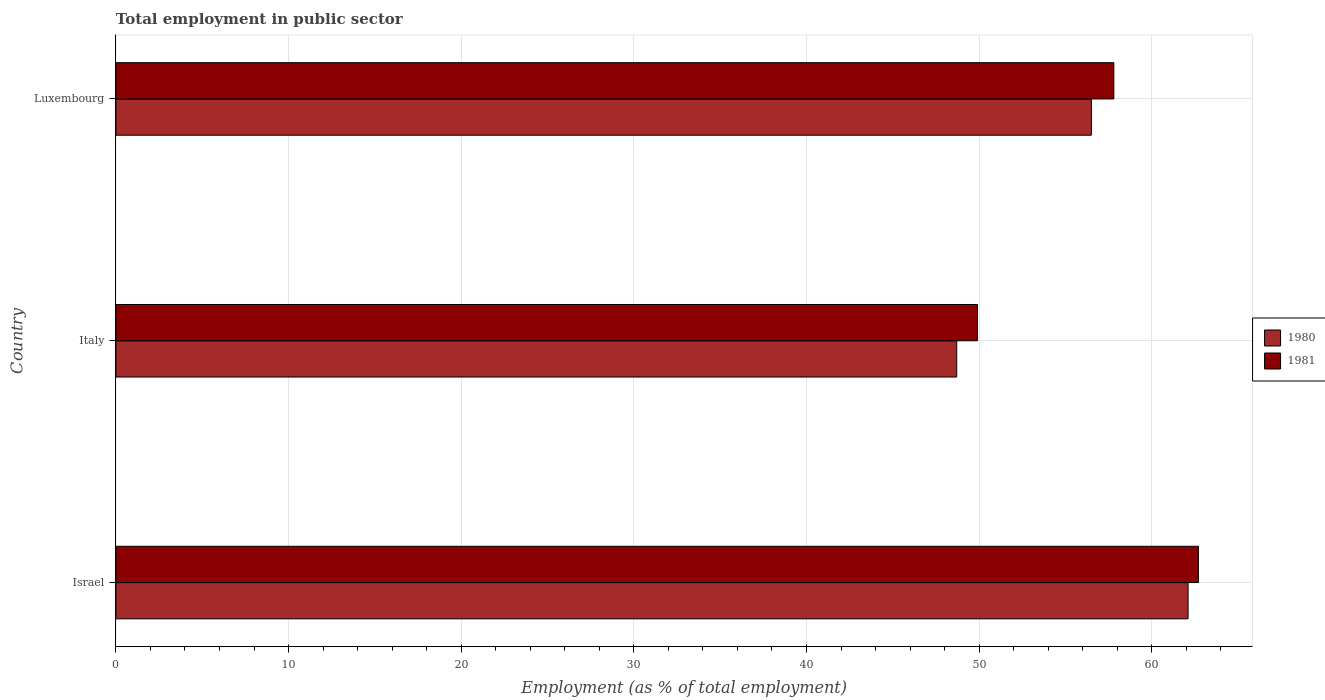How many groups of bars are there?
Your answer should be very brief. 3. In how many cases, is the number of bars for a given country not equal to the number of legend labels?
Offer a very short reply. 0. What is the employment in public sector in 1980 in Israel?
Your response must be concise. 62.1. Across all countries, what is the maximum employment in public sector in 1980?
Offer a very short reply. 62.1. Across all countries, what is the minimum employment in public sector in 1980?
Offer a terse response. 48.7. In which country was the employment in public sector in 1981 maximum?
Give a very brief answer. Israel. In which country was the employment in public sector in 1980 minimum?
Ensure brevity in your answer.  Italy. What is the total employment in public sector in 1980 in the graph?
Keep it short and to the point. 167.3. What is the difference between the employment in public sector in 1980 in Italy and that in Luxembourg?
Your answer should be very brief. -7.8. What is the difference between the employment in public sector in 1980 in Luxembourg and the employment in public sector in 1981 in Israel?
Offer a terse response. -6.2. What is the average employment in public sector in 1981 per country?
Give a very brief answer. 56.8. What is the difference between the employment in public sector in 1980 and employment in public sector in 1981 in Israel?
Your response must be concise. -0.6. What is the ratio of the employment in public sector in 1980 in Israel to that in Italy?
Provide a succinct answer. 1.28. What is the difference between the highest and the second highest employment in public sector in 1980?
Provide a succinct answer. 5.6. What is the difference between the highest and the lowest employment in public sector in 1980?
Provide a succinct answer. 13.4. Is the sum of the employment in public sector in 1980 in Israel and Italy greater than the maximum employment in public sector in 1981 across all countries?
Your answer should be compact. Yes. How many bars are there?
Ensure brevity in your answer.  6. Are all the bars in the graph horizontal?
Your response must be concise. Yes. What is the difference between two consecutive major ticks on the X-axis?
Provide a succinct answer. 10. Are the values on the major ticks of X-axis written in scientific E-notation?
Your answer should be compact. No. Does the graph contain grids?
Keep it short and to the point. Yes. Where does the legend appear in the graph?
Provide a short and direct response. Center right. What is the title of the graph?
Provide a succinct answer. Total employment in public sector. What is the label or title of the X-axis?
Your answer should be compact. Employment (as % of total employment). What is the label or title of the Y-axis?
Ensure brevity in your answer.  Country. What is the Employment (as % of total employment) of 1980 in Israel?
Provide a succinct answer. 62.1. What is the Employment (as % of total employment) of 1981 in Israel?
Make the answer very short. 62.7. What is the Employment (as % of total employment) in 1980 in Italy?
Provide a short and direct response. 48.7. What is the Employment (as % of total employment) in 1981 in Italy?
Keep it short and to the point. 49.9. What is the Employment (as % of total employment) in 1980 in Luxembourg?
Provide a short and direct response. 56.5. What is the Employment (as % of total employment) in 1981 in Luxembourg?
Give a very brief answer. 57.8. Across all countries, what is the maximum Employment (as % of total employment) of 1980?
Provide a short and direct response. 62.1. Across all countries, what is the maximum Employment (as % of total employment) in 1981?
Give a very brief answer. 62.7. Across all countries, what is the minimum Employment (as % of total employment) of 1980?
Make the answer very short. 48.7. Across all countries, what is the minimum Employment (as % of total employment) in 1981?
Provide a succinct answer. 49.9. What is the total Employment (as % of total employment) in 1980 in the graph?
Provide a short and direct response. 167.3. What is the total Employment (as % of total employment) in 1981 in the graph?
Your response must be concise. 170.4. What is the difference between the Employment (as % of total employment) in 1981 in Israel and that in Luxembourg?
Provide a short and direct response. 4.9. What is the difference between the Employment (as % of total employment) of 1980 in Israel and the Employment (as % of total employment) of 1981 in Italy?
Your answer should be compact. 12.2. What is the average Employment (as % of total employment) of 1980 per country?
Keep it short and to the point. 55.77. What is the average Employment (as % of total employment) of 1981 per country?
Provide a short and direct response. 56.8. What is the difference between the Employment (as % of total employment) in 1980 and Employment (as % of total employment) in 1981 in Luxembourg?
Keep it short and to the point. -1.3. What is the ratio of the Employment (as % of total employment) in 1980 in Israel to that in Italy?
Your answer should be very brief. 1.28. What is the ratio of the Employment (as % of total employment) of 1981 in Israel to that in Italy?
Keep it short and to the point. 1.26. What is the ratio of the Employment (as % of total employment) in 1980 in Israel to that in Luxembourg?
Give a very brief answer. 1.1. What is the ratio of the Employment (as % of total employment) of 1981 in Israel to that in Luxembourg?
Provide a short and direct response. 1.08. What is the ratio of the Employment (as % of total employment) in 1980 in Italy to that in Luxembourg?
Give a very brief answer. 0.86. What is the ratio of the Employment (as % of total employment) in 1981 in Italy to that in Luxembourg?
Your response must be concise. 0.86. What is the difference between the highest and the second highest Employment (as % of total employment) in 1980?
Provide a short and direct response. 5.6. What is the difference between the highest and the lowest Employment (as % of total employment) in 1981?
Offer a very short reply. 12.8. 